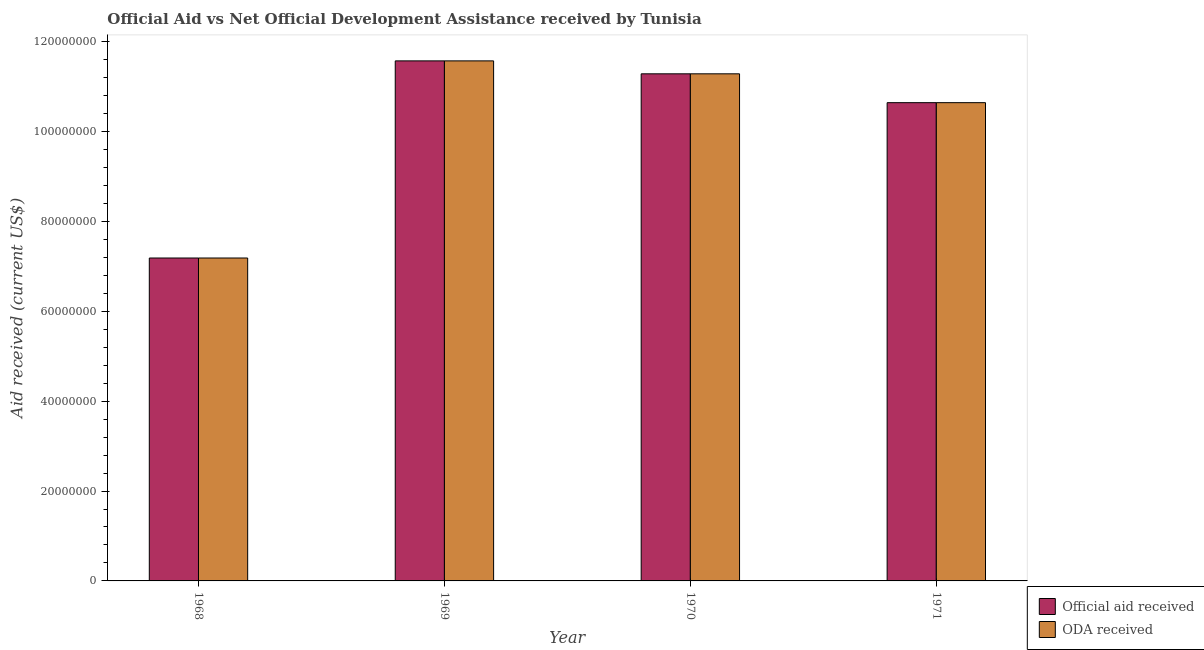How many different coloured bars are there?
Offer a very short reply. 2. Are the number of bars per tick equal to the number of legend labels?
Make the answer very short. Yes. How many bars are there on the 1st tick from the right?
Give a very brief answer. 2. What is the label of the 2nd group of bars from the left?
Your answer should be very brief. 1969. What is the oda received in 1970?
Your answer should be very brief. 1.13e+08. Across all years, what is the maximum official aid received?
Make the answer very short. 1.16e+08. Across all years, what is the minimum official aid received?
Your response must be concise. 7.19e+07. In which year was the oda received maximum?
Your answer should be compact. 1969. In which year was the official aid received minimum?
Your answer should be compact. 1968. What is the total oda received in the graph?
Offer a very short reply. 4.07e+08. What is the difference between the oda received in 1968 and that in 1969?
Make the answer very short. -4.39e+07. What is the difference between the official aid received in 1969 and the oda received in 1970?
Ensure brevity in your answer.  2.88e+06. What is the average official aid received per year?
Ensure brevity in your answer.  1.02e+08. What is the ratio of the official aid received in 1969 to that in 1971?
Your response must be concise. 1.09. Is the official aid received in 1969 less than that in 1971?
Offer a very short reply. No. Is the difference between the oda received in 1970 and 1971 greater than the difference between the official aid received in 1970 and 1971?
Offer a terse response. No. What is the difference between the highest and the second highest official aid received?
Make the answer very short. 2.88e+06. What is the difference between the highest and the lowest oda received?
Offer a terse response. 4.39e+07. In how many years, is the oda received greater than the average oda received taken over all years?
Make the answer very short. 3. What does the 1st bar from the left in 1969 represents?
Your response must be concise. Official aid received. What does the 1st bar from the right in 1969 represents?
Provide a succinct answer. ODA received. How many bars are there?
Ensure brevity in your answer.  8. Are all the bars in the graph horizontal?
Offer a very short reply. No. How many years are there in the graph?
Give a very brief answer. 4. Does the graph contain any zero values?
Provide a short and direct response. No. Does the graph contain grids?
Offer a very short reply. No. Where does the legend appear in the graph?
Give a very brief answer. Bottom right. How many legend labels are there?
Your answer should be compact. 2. What is the title of the graph?
Make the answer very short. Official Aid vs Net Official Development Assistance received by Tunisia . Does "Rural Population" appear as one of the legend labels in the graph?
Make the answer very short. No. What is the label or title of the X-axis?
Keep it short and to the point. Year. What is the label or title of the Y-axis?
Offer a terse response. Aid received (current US$). What is the Aid received (current US$) in Official aid received in 1968?
Your answer should be very brief. 7.19e+07. What is the Aid received (current US$) of ODA received in 1968?
Keep it short and to the point. 7.19e+07. What is the Aid received (current US$) in Official aid received in 1969?
Keep it short and to the point. 1.16e+08. What is the Aid received (current US$) of ODA received in 1969?
Your answer should be compact. 1.16e+08. What is the Aid received (current US$) in Official aid received in 1970?
Provide a succinct answer. 1.13e+08. What is the Aid received (current US$) of ODA received in 1970?
Offer a very short reply. 1.13e+08. What is the Aid received (current US$) in Official aid received in 1971?
Provide a succinct answer. 1.06e+08. What is the Aid received (current US$) of ODA received in 1971?
Give a very brief answer. 1.06e+08. Across all years, what is the maximum Aid received (current US$) of Official aid received?
Your answer should be compact. 1.16e+08. Across all years, what is the maximum Aid received (current US$) in ODA received?
Provide a short and direct response. 1.16e+08. Across all years, what is the minimum Aid received (current US$) in Official aid received?
Your answer should be compact. 7.19e+07. Across all years, what is the minimum Aid received (current US$) of ODA received?
Provide a succinct answer. 7.19e+07. What is the total Aid received (current US$) of Official aid received in the graph?
Your answer should be compact. 4.07e+08. What is the total Aid received (current US$) in ODA received in the graph?
Your response must be concise. 4.07e+08. What is the difference between the Aid received (current US$) of Official aid received in 1968 and that in 1969?
Your answer should be very brief. -4.39e+07. What is the difference between the Aid received (current US$) of ODA received in 1968 and that in 1969?
Provide a short and direct response. -4.39e+07. What is the difference between the Aid received (current US$) in Official aid received in 1968 and that in 1970?
Your response must be concise. -4.10e+07. What is the difference between the Aid received (current US$) in ODA received in 1968 and that in 1970?
Give a very brief answer. -4.10e+07. What is the difference between the Aid received (current US$) in Official aid received in 1968 and that in 1971?
Offer a very short reply. -3.46e+07. What is the difference between the Aid received (current US$) of ODA received in 1968 and that in 1971?
Ensure brevity in your answer.  -3.46e+07. What is the difference between the Aid received (current US$) in Official aid received in 1969 and that in 1970?
Offer a terse response. 2.88e+06. What is the difference between the Aid received (current US$) of ODA received in 1969 and that in 1970?
Ensure brevity in your answer.  2.88e+06. What is the difference between the Aid received (current US$) of Official aid received in 1969 and that in 1971?
Provide a succinct answer. 9.30e+06. What is the difference between the Aid received (current US$) in ODA received in 1969 and that in 1971?
Make the answer very short. 9.30e+06. What is the difference between the Aid received (current US$) in Official aid received in 1970 and that in 1971?
Your answer should be compact. 6.42e+06. What is the difference between the Aid received (current US$) in ODA received in 1970 and that in 1971?
Provide a short and direct response. 6.42e+06. What is the difference between the Aid received (current US$) of Official aid received in 1968 and the Aid received (current US$) of ODA received in 1969?
Your answer should be very brief. -4.39e+07. What is the difference between the Aid received (current US$) of Official aid received in 1968 and the Aid received (current US$) of ODA received in 1970?
Provide a short and direct response. -4.10e+07. What is the difference between the Aid received (current US$) of Official aid received in 1968 and the Aid received (current US$) of ODA received in 1971?
Ensure brevity in your answer.  -3.46e+07. What is the difference between the Aid received (current US$) of Official aid received in 1969 and the Aid received (current US$) of ODA received in 1970?
Offer a terse response. 2.88e+06. What is the difference between the Aid received (current US$) in Official aid received in 1969 and the Aid received (current US$) in ODA received in 1971?
Provide a short and direct response. 9.30e+06. What is the difference between the Aid received (current US$) of Official aid received in 1970 and the Aid received (current US$) of ODA received in 1971?
Ensure brevity in your answer.  6.42e+06. What is the average Aid received (current US$) of Official aid received per year?
Make the answer very short. 1.02e+08. What is the average Aid received (current US$) in ODA received per year?
Give a very brief answer. 1.02e+08. In the year 1970, what is the difference between the Aid received (current US$) in Official aid received and Aid received (current US$) in ODA received?
Provide a short and direct response. 0. In the year 1971, what is the difference between the Aid received (current US$) of Official aid received and Aid received (current US$) of ODA received?
Offer a very short reply. 0. What is the ratio of the Aid received (current US$) in Official aid received in 1968 to that in 1969?
Your answer should be very brief. 0.62. What is the ratio of the Aid received (current US$) in ODA received in 1968 to that in 1969?
Your response must be concise. 0.62. What is the ratio of the Aid received (current US$) of Official aid received in 1968 to that in 1970?
Your answer should be very brief. 0.64. What is the ratio of the Aid received (current US$) in ODA received in 1968 to that in 1970?
Your response must be concise. 0.64. What is the ratio of the Aid received (current US$) in Official aid received in 1968 to that in 1971?
Offer a very short reply. 0.68. What is the ratio of the Aid received (current US$) in ODA received in 1968 to that in 1971?
Provide a short and direct response. 0.68. What is the ratio of the Aid received (current US$) in Official aid received in 1969 to that in 1970?
Make the answer very short. 1.03. What is the ratio of the Aid received (current US$) in ODA received in 1969 to that in 1970?
Provide a short and direct response. 1.03. What is the ratio of the Aid received (current US$) in Official aid received in 1969 to that in 1971?
Your response must be concise. 1.09. What is the ratio of the Aid received (current US$) in ODA received in 1969 to that in 1971?
Your answer should be compact. 1.09. What is the ratio of the Aid received (current US$) of Official aid received in 1970 to that in 1971?
Offer a very short reply. 1.06. What is the ratio of the Aid received (current US$) in ODA received in 1970 to that in 1971?
Give a very brief answer. 1.06. What is the difference between the highest and the second highest Aid received (current US$) in Official aid received?
Provide a short and direct response. 2.88e+06. What is the difference between the highest and the second highest Aid received (current US$) in ODA received?
Offer a very short reply. 2.88e+06. What is the difference between the highest and the lowest Aid received (current US$) of Official aid received?
Provide a short and direct response. 4.39e+07. What is the difference between the highest and the lowest Aid received (current US$) of ODA received?
Provide a succinct answer. 4.39e+07. 